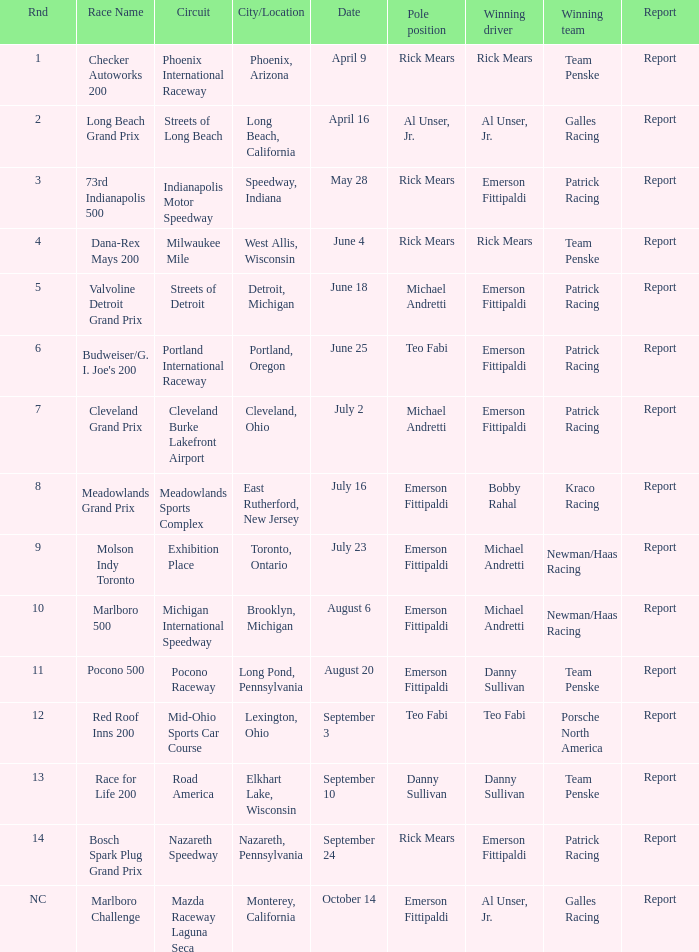How many winning drivers were the for the rnd equalling 5? 1.0. 